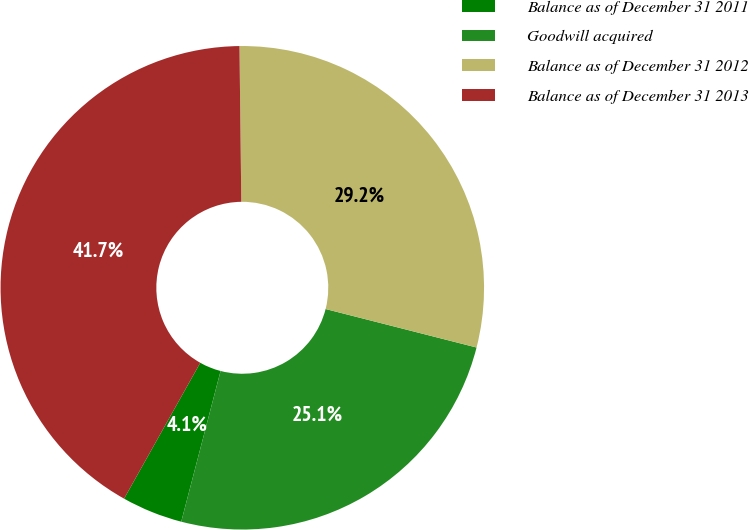<chart> <loc_0><loc_0><loc_500><loc_500><pie_chart><fcel>Balance as of December 31 2011<fcel>Goodwill acquired<fcel>Balance as of December 31 2012<fcel>Balance as of December 31 2013<nl><fcel>4.07%<fcel>25.09%<fcel>29.16%<fcel>41.68%<nl></chart> 